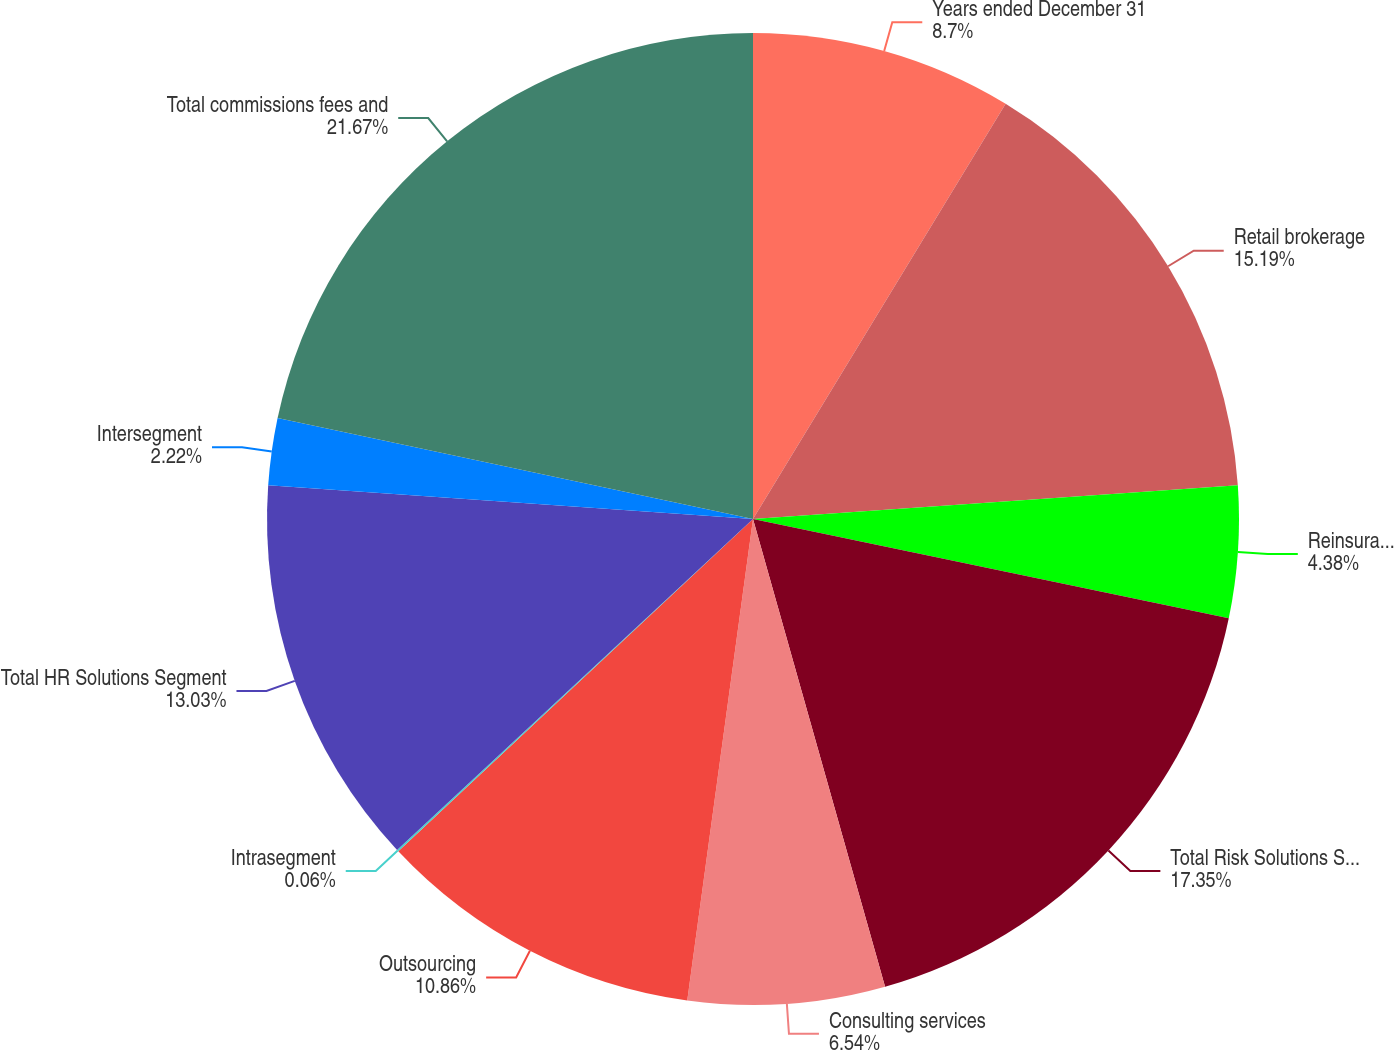Convert chart. <chart><loc_0><loc_0><loc_500><loc_500><pie_chart><fcel>Years ended December 31<fcel>Retail brokerage<fcel>Reinsurance brokerage<fcel>Total Risk Solutions Segment<fcel>Consulting services<fcel>Outsourcing<fcel>Intrasegment<fcel>Total HR Solutions Segment<fcel>Intersegment<fcel>Total commissions fees and<nl><fcel>8.7%<fcel>15.19%<fcel>4.38%<fcel>17.35%<fcel>6.54%<fcel>10.86%<fcel>0.06%<fcel>13.03%<fcel>2.22%<fcel>21.67%<nl></chart> 